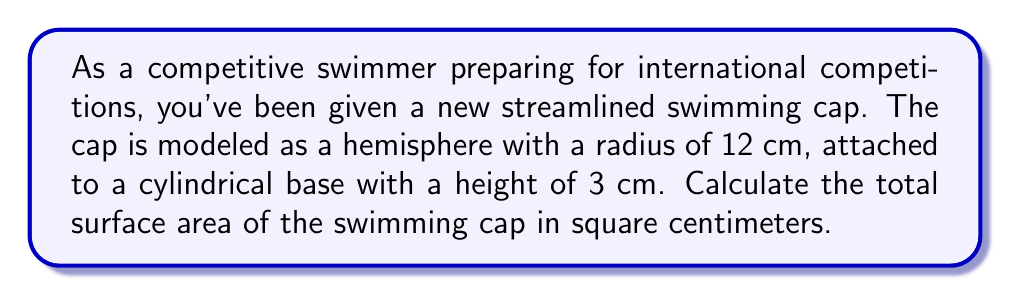Can you solve this math problem? Let's break this problem down into steps:

1) The swimming cap consists of two parts: a hemisphere and a cylinder.

2) For the hemisphere:
   - The surface area of a hemisphere is given by the formula: $A_h = 2\pi r^2$
   - Where $r$ is the radius of the hemisphere
   - $A_h = 2\pi (12 \text{ cm})^2 = 2\pi (144 \text{ cm}^2) = 288\pi \text{ cm}^2$

3) For the cylindrical base:
   - We need to calculate the lateral surface area (the curved part)
   - The formula for the lateral surface area of a cylinder is: $A_c = 2\pi rh$
   - Where $r$ is the radius of the base and $h$ is the height
   - $A_c = 2\pi (12 \text{ cm})(3 \text{ cm}) = 72\pi \text{ cm}^2$

4) The total surface area is the sum of these two parts:
   $$A_{\text{total}} = A_h + A_c = 288\pi \text{ cm}^2 + 72\pi \text{ cm}^2 = 360\pi \text{ cm}^2$$

5) To get the final answer in square centimeters:
   $$A_{\text{total}} = 360\pi \text{ cm}^2 \approx 1130.97 \text{ cm}^2$$

[asy]
import geometry;

size(200);

// Draw cylinder
path p = (0,0)--(0,3)--(24,3)--(24,0)--cycle;
draw(p);
draw((0,3)..(12,6)..(24,3));

// Draw hemisphere
draw(arc((12,3),12,0,180));

// Labels
label("12 cm", (12,-2));
label("3 cm", (26,1.5));

[/asy]
Answer: The total surface area of the streamlined swimming cap is approximately 1130.97 cm². 